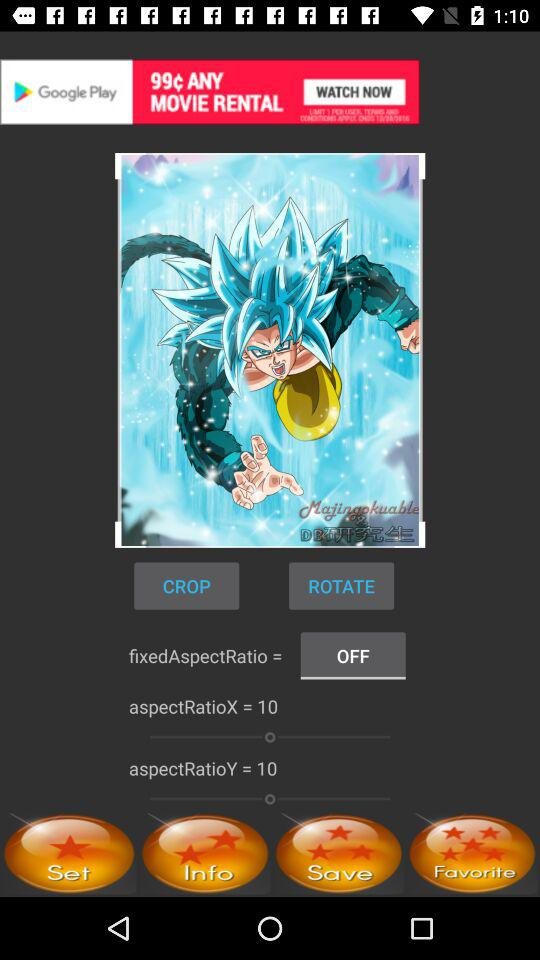What is the setting for aspectRatioY? The setting for aspectRatioY is 10. 